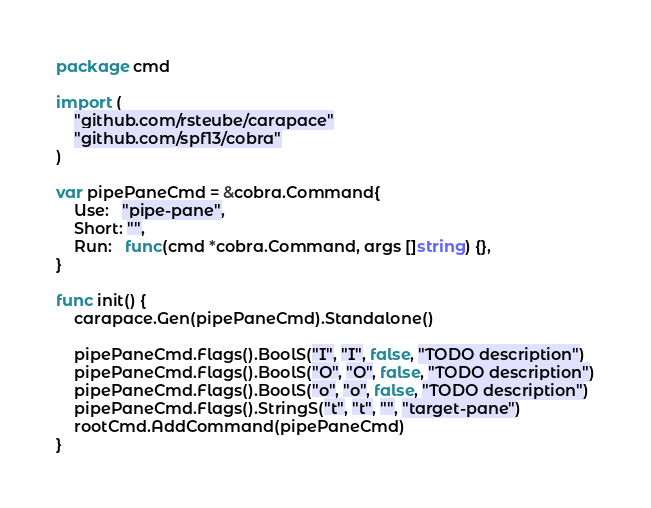Convert code to text. <code><loc_0><loc_0><loc_500><loc_500><_Go_>package cmd

import (
	"github.com/rsteube/carapace"
	"github.com/spf13/cobra"
)

var pipePaneCmd = &cobra.Command{
	Use:   "pipe-pane",
	Short: "",
	Run:   func(cmd *cobra.Command, args []string) {},
}

func init() {
	carapace.Gen(pipePaneCmd).Standalone()

	pipePaneCmd.Flags().BoolS("I", "I", false, "TODO description")
	pipePaneCmd.Flags().BoolS("O", "O", false, "TODO description")
	pipePaneCmd.Flags().BoolS("o", "o", false, "TODO description")
	pipePaneCmd.Flags().StringS("t", "t", "", "target-pane")
	rootCmd.AddCommand(pipePaneCmd)
}
</code> 